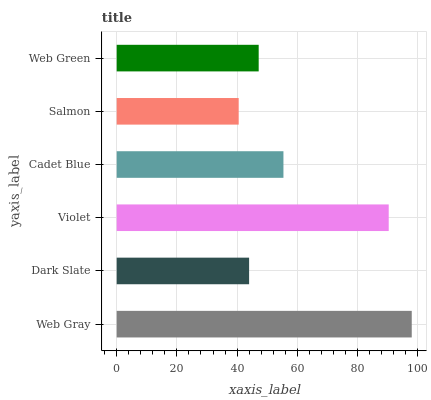Is Salmon the minimum?
Answer yes or no. Yes. Is Web Gray the maximum?
Answer yes or no. Yes. Is Dark Slate the minimum?
Answer yes or no. No. Is Dark Slate the maximum?
Answer yes or no. No. Is Web Gray greater than Dark Slate?
Answer yes or no. Yes. Is Dark Slate less than Web Gray?
Answer yes or no. Yes. Is Dark Slate greater than Web Gray?
Answer yes or no. No. Is Web Gray less than Dark Slate?
Answer yes or no. No. Is Cadet Blue the high median?
Answer yes or no. Yes. Is Web Green the low median?
Answer yes or no. Yes. Is Web Gray the high median?
Answer yes or no. No. Is Web Gray the low median?
Answer yes or no. No. 